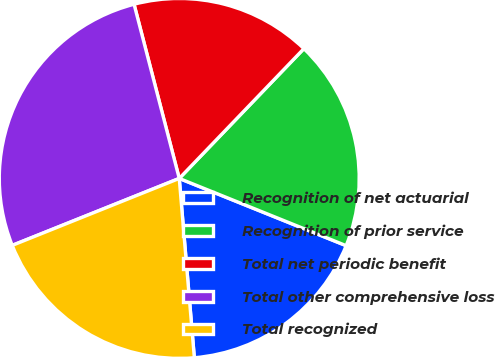Convert chart. <chart><loc_0><loc_0><loc_500><loc_500><pie_chart><fcel>Recognition of net actuarial<fcel>Recognition of prior service<fcel>Total net periodic benefit<fcel>Total other comprehensive loss<fcel>Total recognized<nl><fcel>17.57%<fcel>18.92%<fcel>16.22%<fcel>27.03%<fcel>20.27%<nl></chart> 